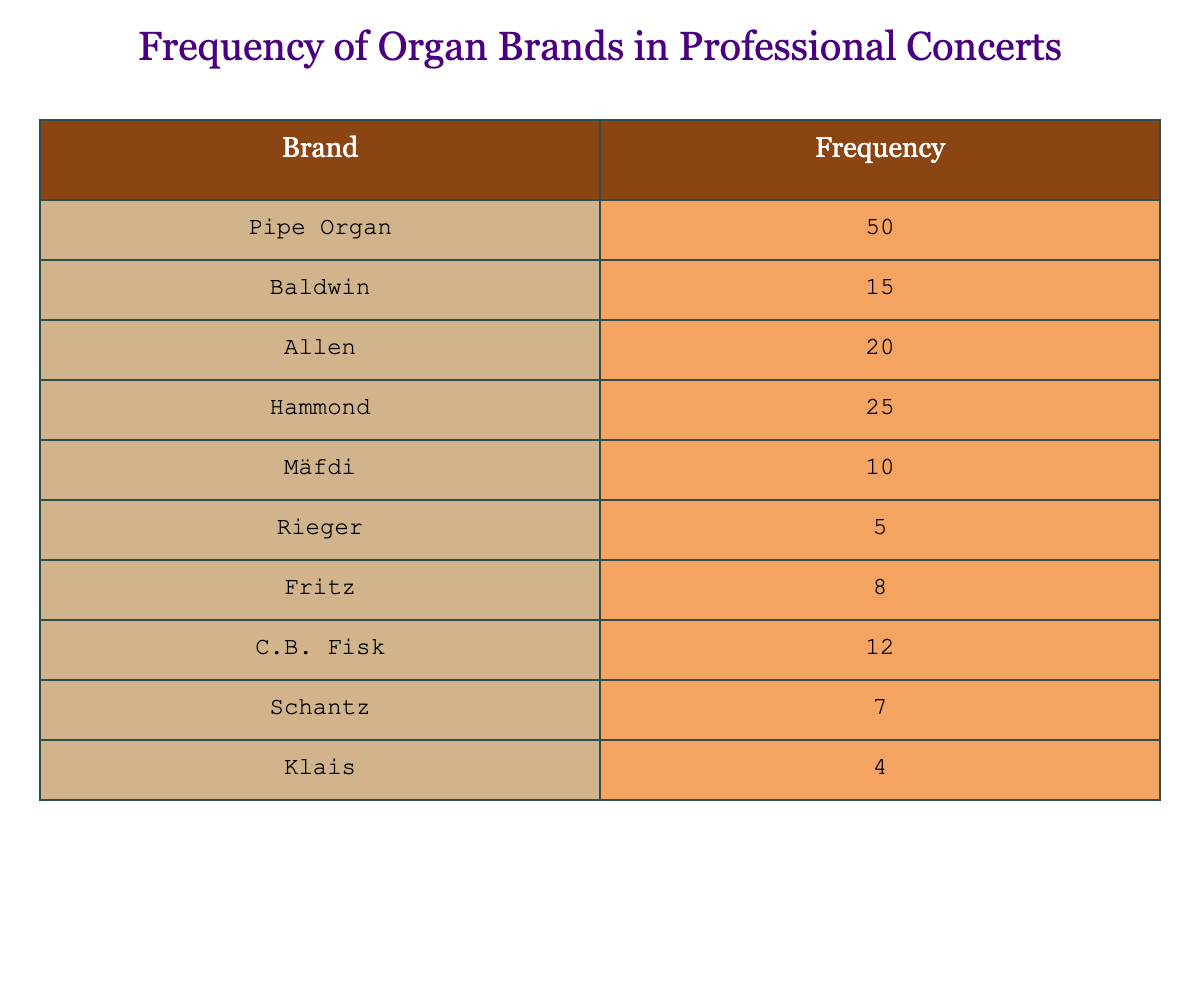What is the frequency of the Pipe Organ brand? The table shows the frequency for each organ brand, and for Pipe Organ, the frequency is listed directly as 50.
Answer: 50 Which brand has the lowest frequency? The table indicates that Klais has the lowest frequency at 4, as it is the smallest number in the frequency column.
Answer: Klais What is the total frequency for all organ brands listed? To find the total frequency, we sum all the listed frequencies: 50 + 15 + 20 + 25 + 10 + 5 + 8 + 12 + 7 + 4 = 156.
Answer: 156 Is there a brand that has a frequency of exactly 12? By scanning the table, we can see that C.B. Fisk has a frequency of 12, confirming that there is such a brand.
Answer: Yes Which brand has a frequency that is more than the average frequency of all brands? First, we calculate the average frequency: total frequency (156) divided by the number of brands (10) gives us an average of 15.6. The brands with frequencies higher than this average are Pipe Organ (50), Hammond (25), Allen (20), and Baldwin (15).
Answer: Pipe Organ, Hammond, Allen How many more organs are used compared to the least used brand? Klais is the least used brand with a frequency of 4. The next least used is Rieger with a frequency of 5. Therefore, the frequency of Rieger (5) minus Klais (4) gives us a difference of 1.
Answer: 1 What percentage of the total frequency does the Baldwin brand represent? Baldwin has a frequency of 15. To find the percentage, we take Baldwin's frequency divided by the total frequency (156), then multiply by 100: (15/156) * 100 = approximately 9.62%.
Answer: 9.62% How many brands have a frequency of over 20? By looking at the table, the brands with frequencies above 20 are: Pipe Organ (50), Hammond (25), and Allen (20). The frequencies of Pipe Organ and Hammond qualify, giving us a total of 2 brands.
Answer: 2 Which brands collectively account for more than half of the total frequency? Half of the total frequency (156) is 78. To determine which brands contribute to this, we can start adding from the highest frequency down. Pipe Organ (50) + Hammond (25) + Allen (20) + Baldwin (15) = 110, which exceeds 78. Thus, these four brands collectively account for more than half.
Answer: Pipe Organ, Hammond, Allen, Baldwin 